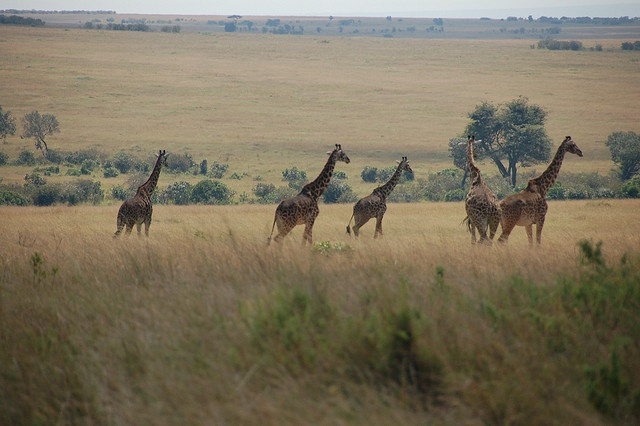Describe the objects in this image and their specific colors. I can see giraffe in lightgray, black, gray, and maroon tones, giraffe in lightgray, gray, and black tones, and giraffe in lightgray, gray, and black tones in this image. 